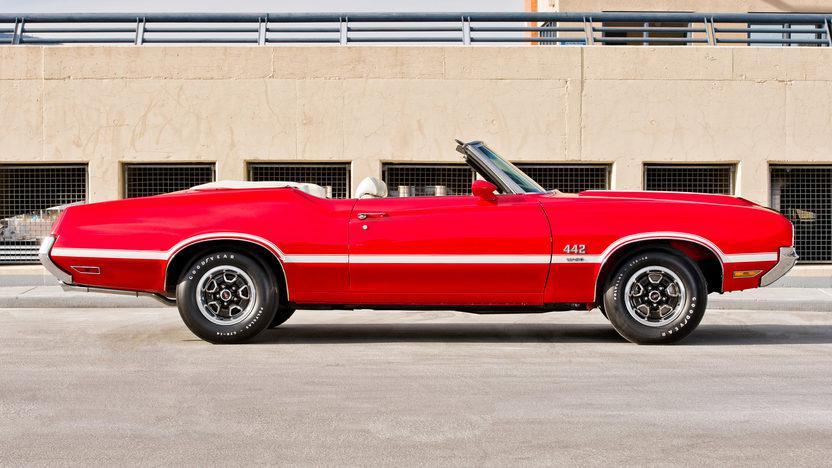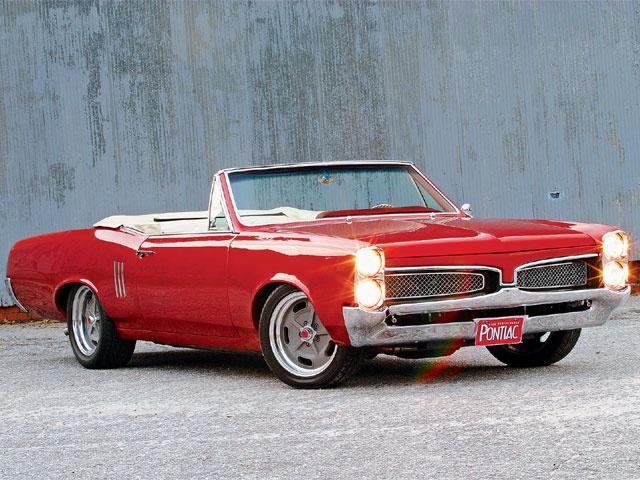The first image is the image on the left, the second image is the image on the right. Evaluate the accuracy of this statement regarding the images: "In each image, the front grille of the car is visible.". Is it true? Answer yes or no. No. 